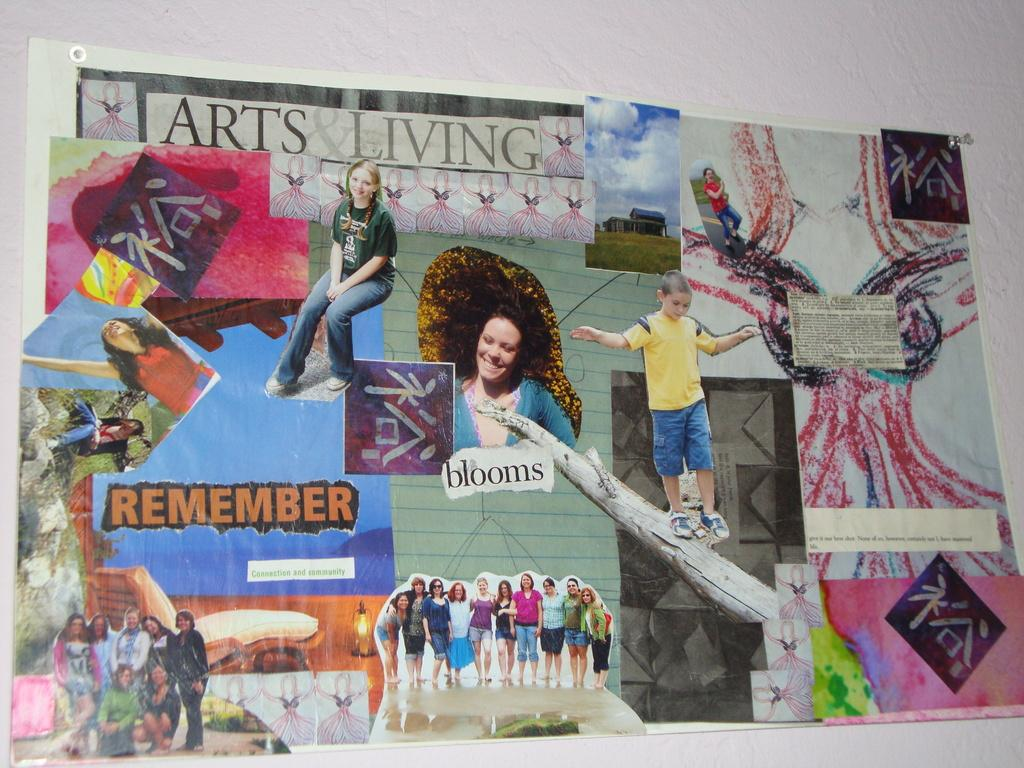Provide a one-sentence caption for the provided image. A art collage of many random things with the words Arts Living at the top. 